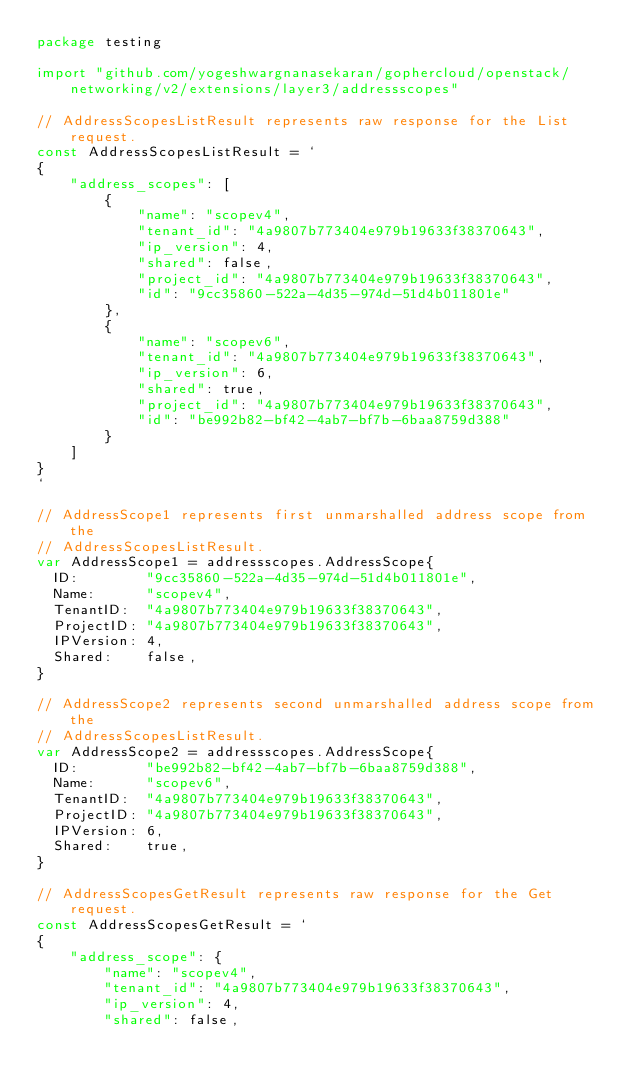<code> <loc_0><loc_0><loc_500><loc_500><_Go_>package testing

import "github.com/yogeshwargnanasekaran/gophercloud/openstack/networking/v2/extensions/layer3/addressscopes"

// AddressScopesListResult represents raw response for the List request.
const AddressScopesListResult = `
{
    "address_scopes": [
        {
            "name": "scopev4",
            "tenant_id": "4a9807b773404e979b19633f38370643",
            "ip_version": 4,
            "shared": false,
            "project_id": "4a9807b773404e979b19633f38370643",
            "id": "9cc35860-522a-4d35-974d-51d4b011801e"
        },
        {
            "name": "scopev6",
            "tenant_id": "4a9807b773404e979b19633f38370643",
            "ip_version": 6,
            "shared": true,
            "project_id": "4a9807b773404e979b19633f38370643",
            "id": "be992b82-bf42-4ab7-bf7b-6baa8759d388"
        }
    ]
}
`

// AddressScope1 represents first unmarshalled address scope from the
// AddressScopesListResult.
var AddressScope1 = addressscopes.AddressScope{
	ID:        "9cc35860-522a-4d35-974d-51d4b011801e",
	Name:      "scopev4",
	TenantID:  "4a9807b773404e979b19633f38370643",
	ProjectID: "4a9807b773404e979b19633f38370643",
	IPVersion: 4,
	Shared:    false,
}

// AddressScope2 represents second unmarshalled address scope from the
// AddressScopesListResult.
var AddressScope2 = addressscopes.AddressScope{
	ID:        "be992b82-bf42-4ab7-bf7b-6baa8759d388",
	Name:      "scopev6",
	TenantID:  "4a9807b773404e979b19633f38370643",
	ProjectID: "4a9807b773404e979b19633f38370643",
	IPVersion: 6,
	Shared:    true,
}

// AddressScopesGetResult represents raw response for the Get request.
const AddressScopesGetResult = `
{
    "address_scope": {
        "name": "scopev4",
        "tenant_id": "4a9807b773404e979b19633f38370643",
        "ip_version": 4,
        "shared": false,</code> 